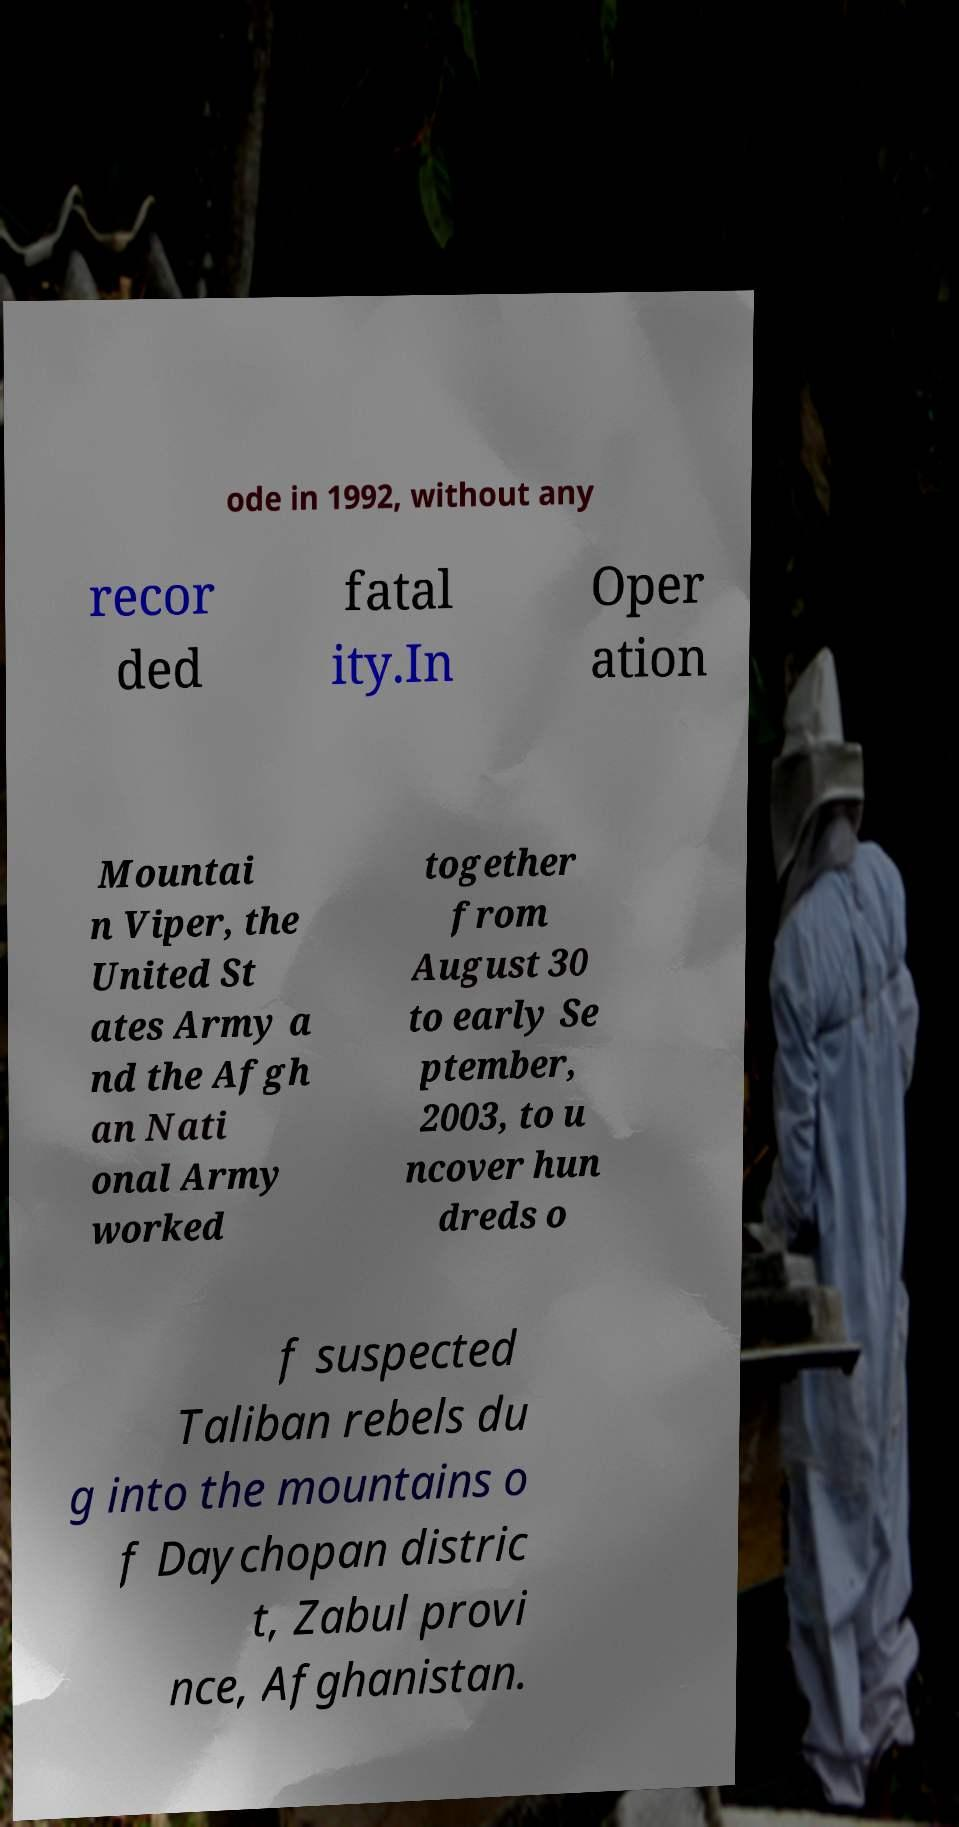For documentation purposes, I need the text within this image transcribed. Could you provide that? ode in 1992, without any recor ded fatal ity.In Oper ation Mountai n Viper, the United St ates Army a nd the Afgh an Nati onal Army worked together from August 30 to early Se ptember, 2003, to u ncover hun dreds o f suspected Taliban rebels du g into the mountains o f Daychopan distric t, Zabul provi nce, Afghanistan. 